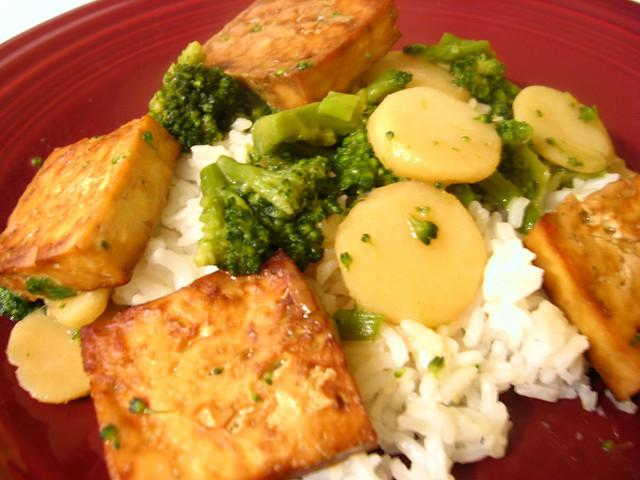Which item on the plate is highest in carbs? rice 